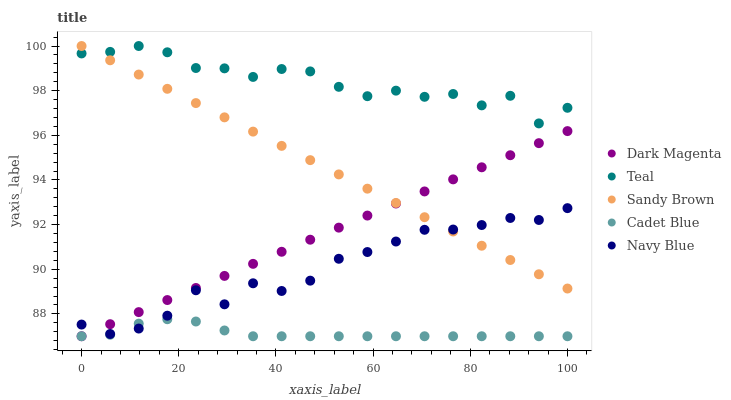Does Cadet Blue have the minimum area under the curve?
Answer yes or no. Yes. Does Teal have the maximum area under the curve?
Answer yes or no. Yes. Does Sandy Brown have the minimum area under the curve?
Answer yes or no. No. Does Sandy Brown have the maximum area under the curve?
Answer yes or no. No. Is Sandy Brown the smoothest?
Answer yes or no. Yes. Is Teal the roughest?
Answer yes or no. Yes. Is Cadet Blue the smoothest?
Answer yes or no. No. Is Cadet Blue the roughest?
Answer yes or no. No. Does Cadet Blue have the lowest value?
Answer yes or no. Yes. Does Sandy Brown have the lowest value?
Answer yes or no. No. Does Teal have the highest value?
Answer yes or no. Yes. Does Cadet Blue have the highest value?
Answer yes or no. No. Is Cadet Blue less than Teal?
Answer yes or no. Yes. Is Teal greater than Dark Magenta?
Answer yes or no. Yes. Does Navy Blue intersect Cadet Blue?
Answer yes or no. Yes. Is Navy Blue less than Cadet Blue?
Answer yes or no. No. Is Navy Blue greater than Cadet Blue?
Answer yes or no. No. Does Cadet Blue intersect Teal?
Answer yes or no. No. 